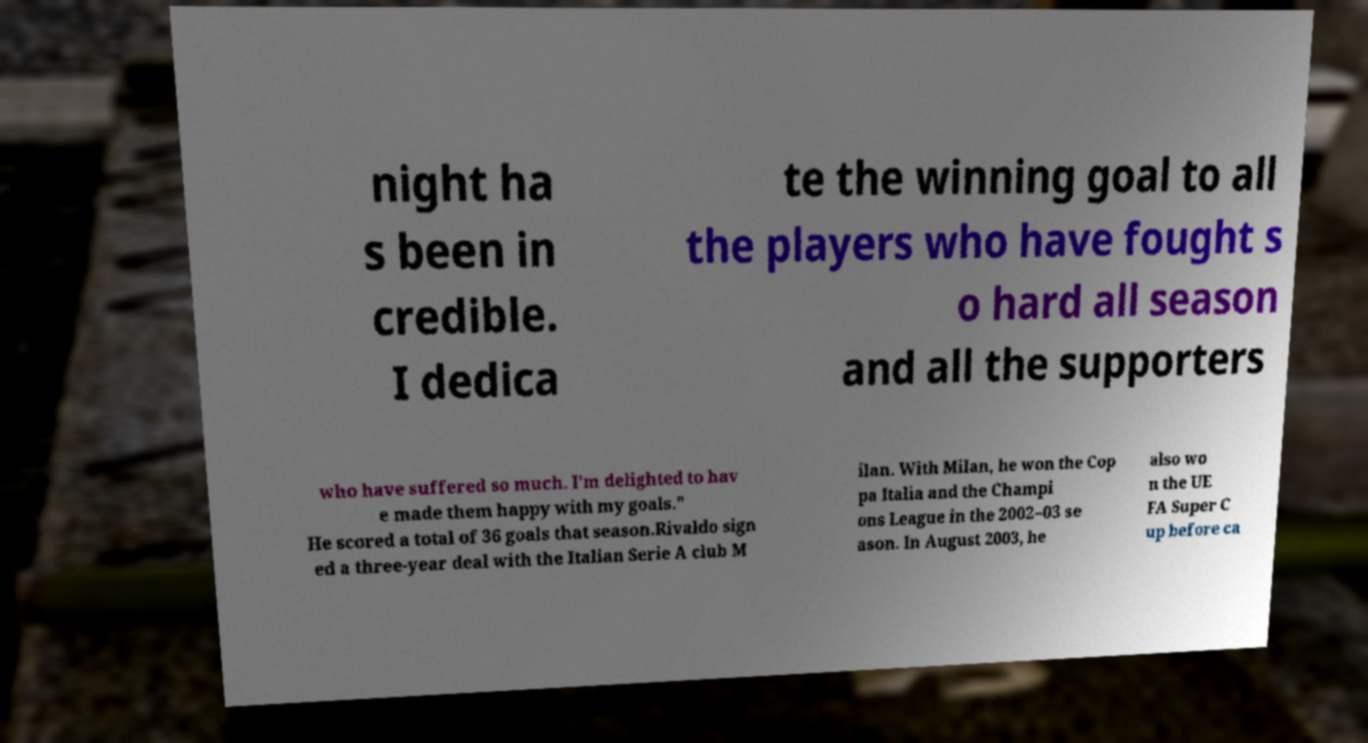Please read and relay the text visible in this image. What does it say? night ha s been in credible. I dedica te the winning goal to all the players who have fought s o hard all season and all the supporters who have suffered so much. I'm delighted to hav e made them happy with my goals." He scored a total of 36 goals that season.Rivaldo sign ed a three-year deal with the Italian Serie A club M ilan. With Milan, he won the Cop pa Italia and the Champi ons League in the 2002–03 se ason. In August 2003, he also wo n the UE FA Super C up before ca 